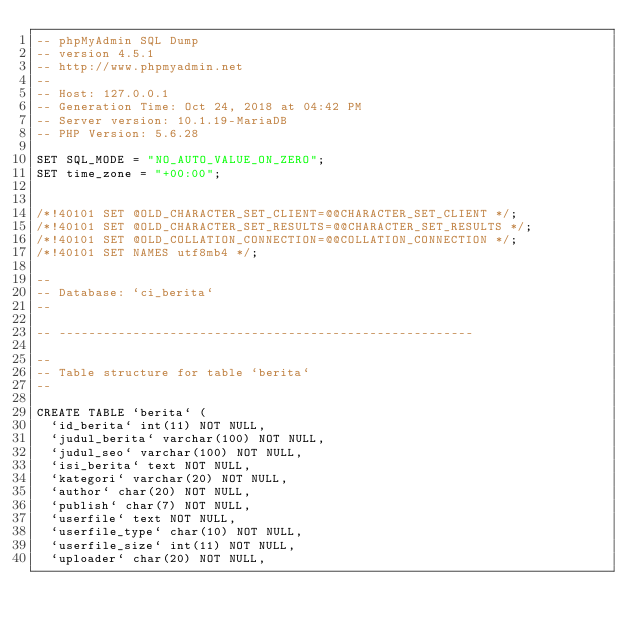<code> <loc_0><loc_0><loc_500><loc_500><_SQL_>-- phpMyAdmin SQL Dump
-- version 4.5.1
-- http://www.phpmyadmin.net
--
-- Host: 127.0.0.1
-- Generation Time: Oct 24, 2018 at 04:42 PM
-- Server version: 10.1.19-MariaDB
-- PHP Version: 5.6.28

SET SQL_MODE = "NO_AUTO_VALUE_ON_ZERO";
SET time_zone = "+00:00";


/*!40101 SET @OLD_CHARACTER_SET_CLIENT=@@CHARACTER_SET_CLIENT */;
/*!40101 SET @OLD_CHARACTER_SET_RESULTS=@@CHARACTER_SET_RESULTS */;
/*!40101 SET @OLD_COLLATION_CONNECTION=@@COLLATION_CONNECTION */;
/*!40101 SET NAMES utf8mb4 */;

--
-- Database: `ci_berita`
--

-- --------------------------------------------------------

--
-- Table structure for table `berita`
--

CREATE TABLE `berita` (
  `id_berita` int(11) NOT NULL,
  `judul_berita` varchar(100) NOT NULL,
  `judul_seo` varchar(100) NOT NULL,
  `isi_berita` text NOT NULL,
  `kategori` varchar(20) NOT NULL,
  `author` char(20) NOT NULL,
  `publish` char(7) NOT NULL,
  `userfile` text NOT NULL,
  `userfile_type` char(10) NOT NULL,
  `userfile_size` int(11) NOT NULL,
  `uploader` char(20) NOT NULL,</code> 